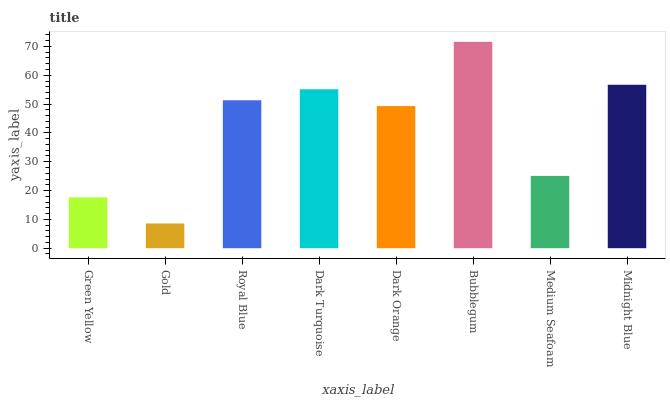Is Gold the minimum?
Answer yes or no. Yes. Is Bubblegum the maximum?
Answer yes or no. Yes. Is Royal Blue the minimum?
Answer yes or no. No. Is Royal Blue the maximum?
Answer yes or no. No. Is Royal Blue greater than Gold?
Answer yes or no. Yes. Is Gold less than Royal Blue?
Answer yes or no. Yes. Is Gold greater than Royal Blue?
Answer yes or no. No. Is Royal Blue less than Gold?
Answer yes or no. No. Is Royal Blue the high median?
Answer yes or no. Yes. Is Dark Orange the low median?
Answer yes or no. Yes. Is Dark Orange the high median?
Answer yes or no. No. Is Bubblegum the low median?
Answer yes or no. No. 